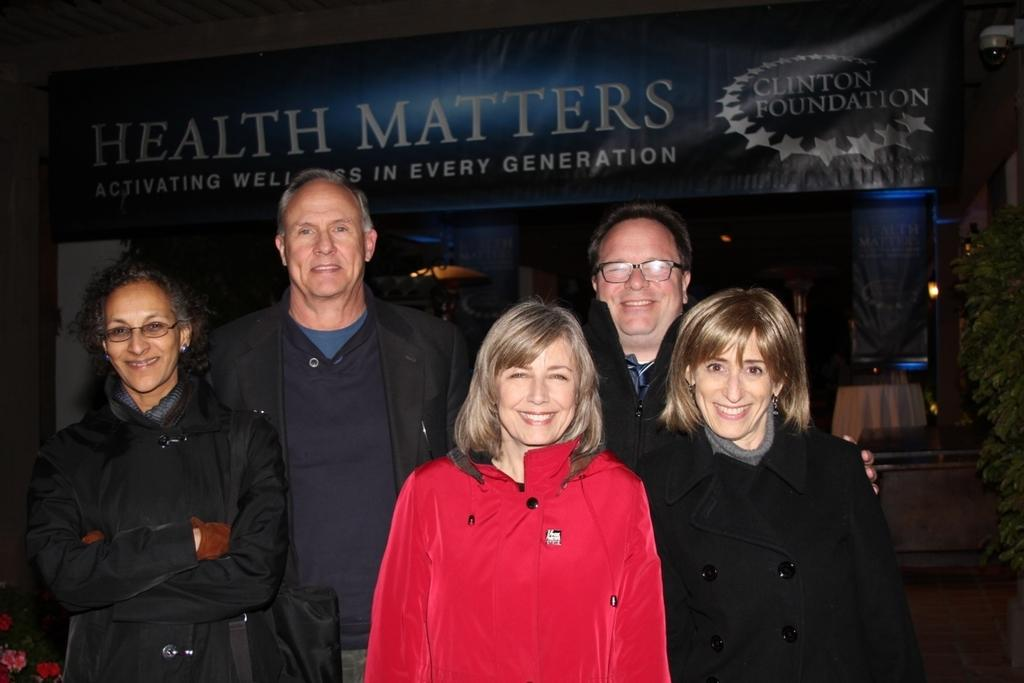How many people are in the image? There is a group of persons standing in the image. What can be seen in the background of the image? There is a banner, a camera, a tree, and a wall in the background of the image. What type of pickle is being used as a prop in the image? There is no pickle present in the image. What kind of battle is taking place in the image? There is no battle depicted in the image. 